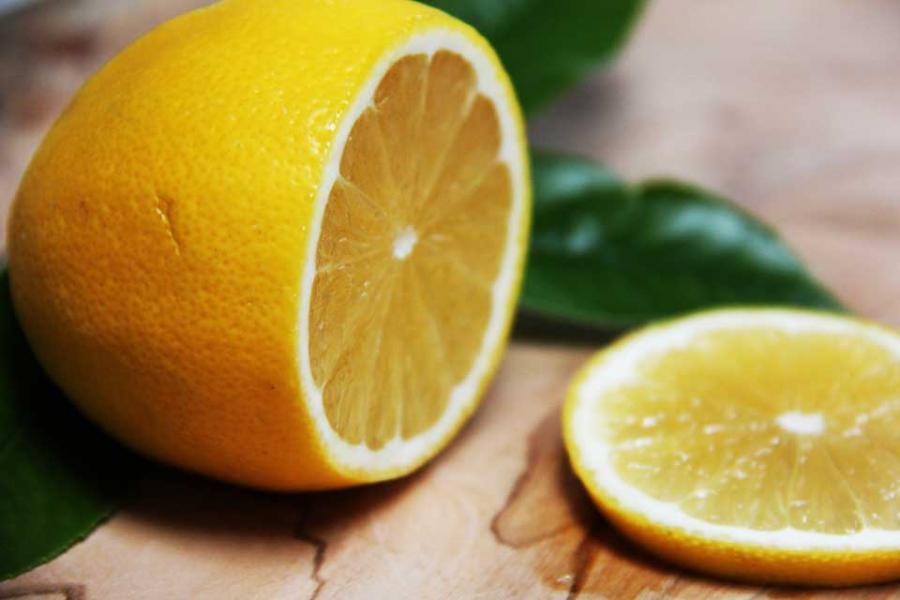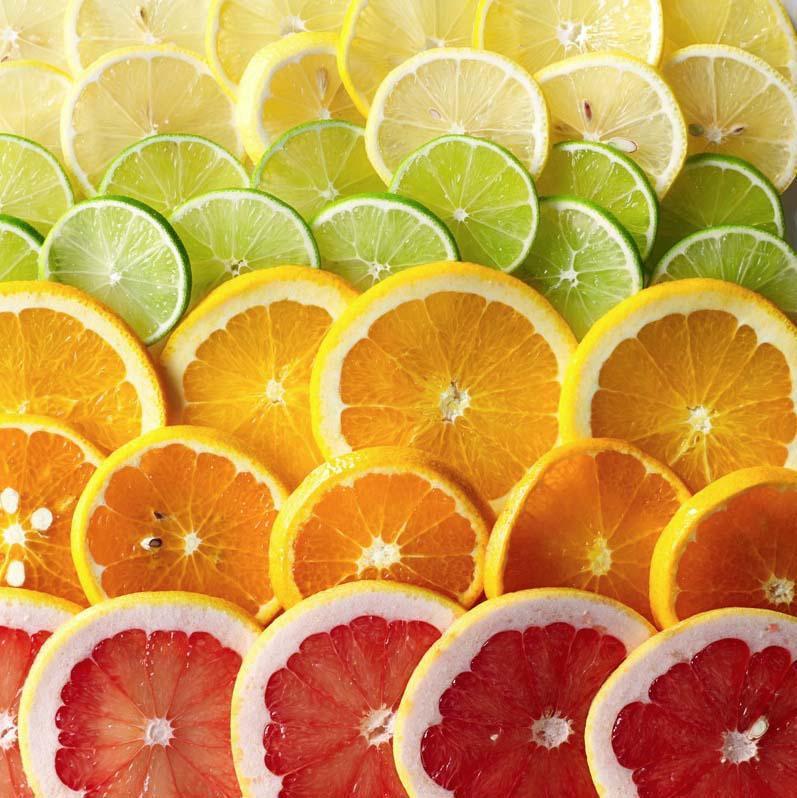The first image is the image on the left, the second image is the image on the right. For the images shown, is this caption "The left image includes a variety of whole citrus fruits, along with at least one cut fruit and green leaves." true? Answer yes or no. No. 